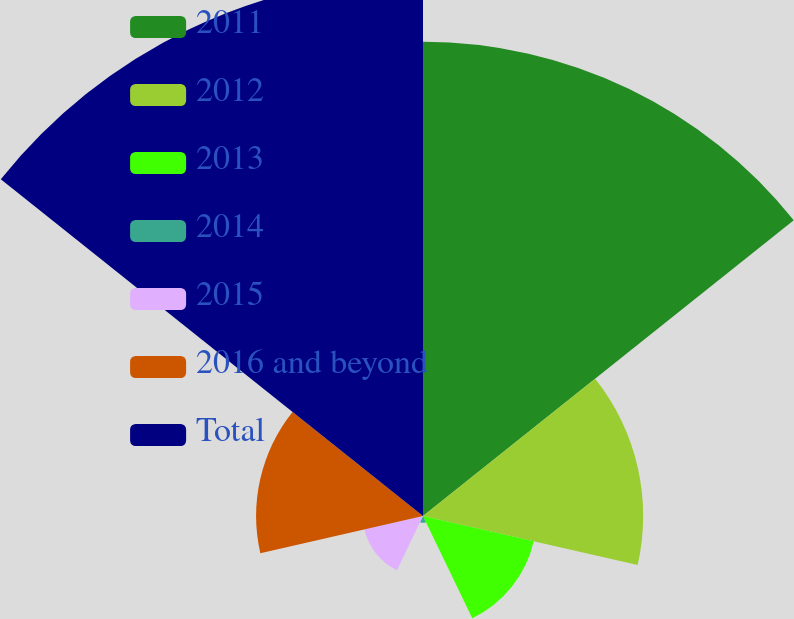<chart> <loc_0><loc_0><loc_500><loc_500><pie_chart><fcel>2011<fcel>2012<fcel>2013<fcel>2014<fcel>2015<fcel>2016 and beyond<fcel>Total<nl><fcel>29.98%<fcel>13.92%<fcel>7.18%<fcel>0.43%<fcel>3.8%<fcel>10.55%<fcel>34.14%<nl></chart> 